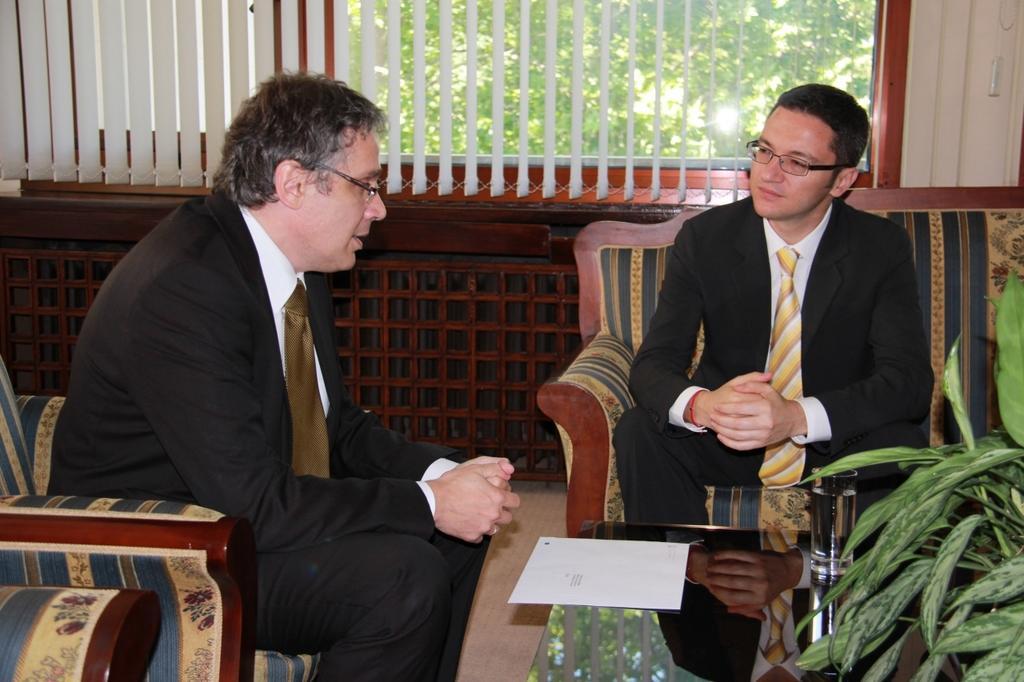Could you give a brief overview of what you see in this image? This picture shows two men sitting on chairs in front of a table, there is a water glass on the table and we can see one paper, on the right bottom of the image we can see a plant, in the background the window blind from the window we can see a tree. 